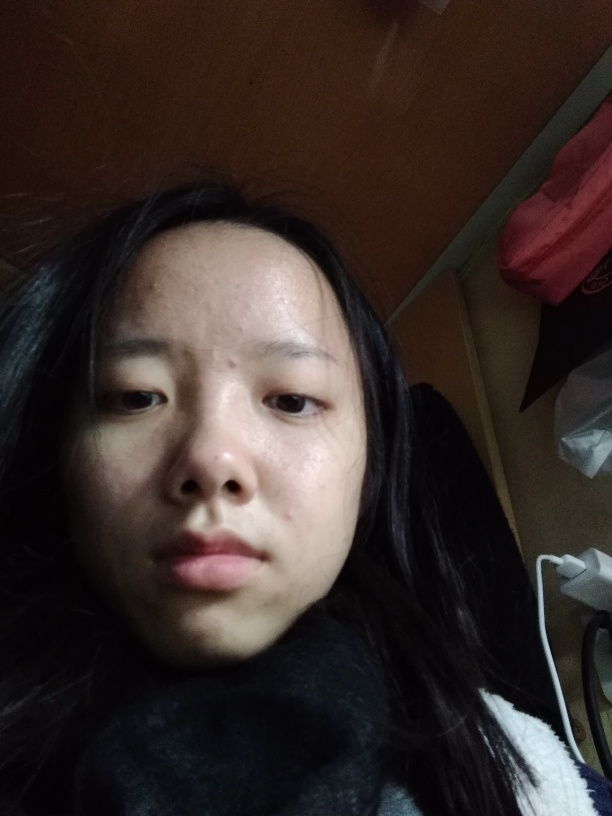Can you describe the lighting in the image? The lighting in the image appears to be soft and natural, diffused evenly across the subject's face. There are no harsh shadows or bright highlights that would suggest the presence of direct or strong artificial light sources. 